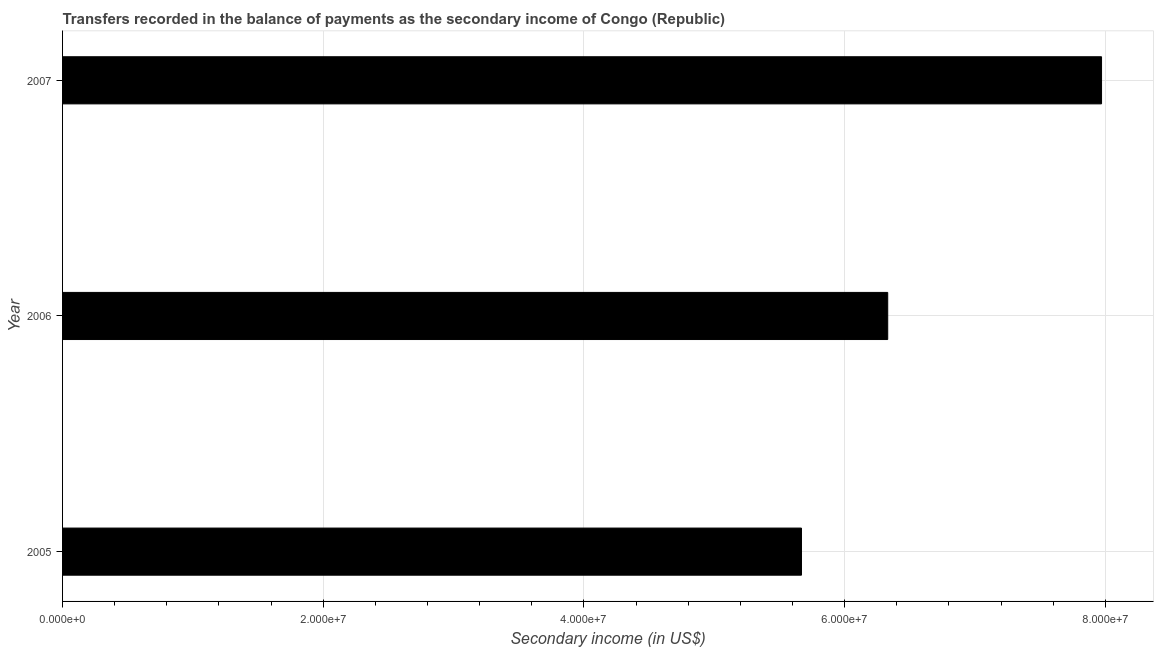Does the graph contain any zero values?
Your answer should be very brief. No. Does the graph contain grids?
Give a very brief answer. Yes. What is the title of the graph?
Your response must be concise. Transfers recorded in the balance of payments as the secondary income of Congo (Republic). What is the label or title of the X-axis?
Provide a succinct answer. Secondary income (in US$). What is the label or title of the Y-axis?
Make the answer very short. Year. What is the amount of secondary income in 2006?
Your answer should be compact. 6.33e+07. Across all years, what is the maximum amount of secondary income?
Make the answer very short. 7.97e+07. Across all years, what is the minimum amount of secondary income?
Make the answer very short. 5.67e+07. In which year was the amount of secondary income maximum?
Your answer should be compact. 2007. What is the sum of the amount of secondary income?
Make the answer very short. 2.00e+08. What is the difference between the amount of secondary income in 2006 and 2007?
Make the answer very short. -1.64e+07. What is the average amount of secondary income per year?
Offer a terse response. 6.66e+07. What is the median amount of secondary income?
Keep it short and to the point. 6.33e+07. Do a majority of the years between 2007 and 2005 (inclusive) have amount of secondary income greater than 68000000 US$?
Your response must be concise. Yes. What is the ratio of the amount of secondary income in 2006 to that in 2007?
Your response must be concise. 0.79. Is the amount of secondary income in 2005 less than that in 2007?
Your response must be concise. Yes. Is the difference between the amount of secondary income in 2005 and 2007 greater than the difference between any two years?
Provide a short and direct response. Yes. What is the difference between the highest and the second highest amount of secondary income?
Provide a short and direct response. 1.64e+07. Is the sum of the amount of secondary income in 2005 and 2006 greater than the maximum amount of secondary income across all years?
Offer a very short reply. Yes. What is the difference between the highest and the lowest amount of secondary income?
Offer a very short reply. 2.30e+07. How many years are there in the graph?
Your answer should be very brief. 3. Are the values on the major ticks of X-axis written in scientific E-notation?
Make the answer very short. Yes. What is the Secondary income (in US$) in 2005?
Provide a succinct answer. 5.67e+07. What is the Secondary income (in US$) of 2006?
Provide a short and direct response. 6.33e+07. What is the Secondary income (in US$) of 2007?
Your response must be concise. 7.97e+07. What is the difference between the Secondary income (in US$) in 2005 and 2006?
Your response must be concise. -6.62e+06. What is the difference between the Secondary income (in US$) in 2005 and 2007?
Ensure brevity in your answer.  -2.30e+07. What is the difference between the Secondary income (in US$) in 2006 and 2007?
Make the answer very short. -1.64e+07. What is the ratio of the Secondary income (in US$) in 2005 to that in 2006?
Ensure brevity in your answer.  0.9. What is the ratio of the Secondary income (in US$) in 2005 to that in 2007?
Provide a succinct answer. 0.71. What is the ratio of the Secondary income (in US$) in 2006 to that in 2007?
Keep it short and to the point. 0.79. 